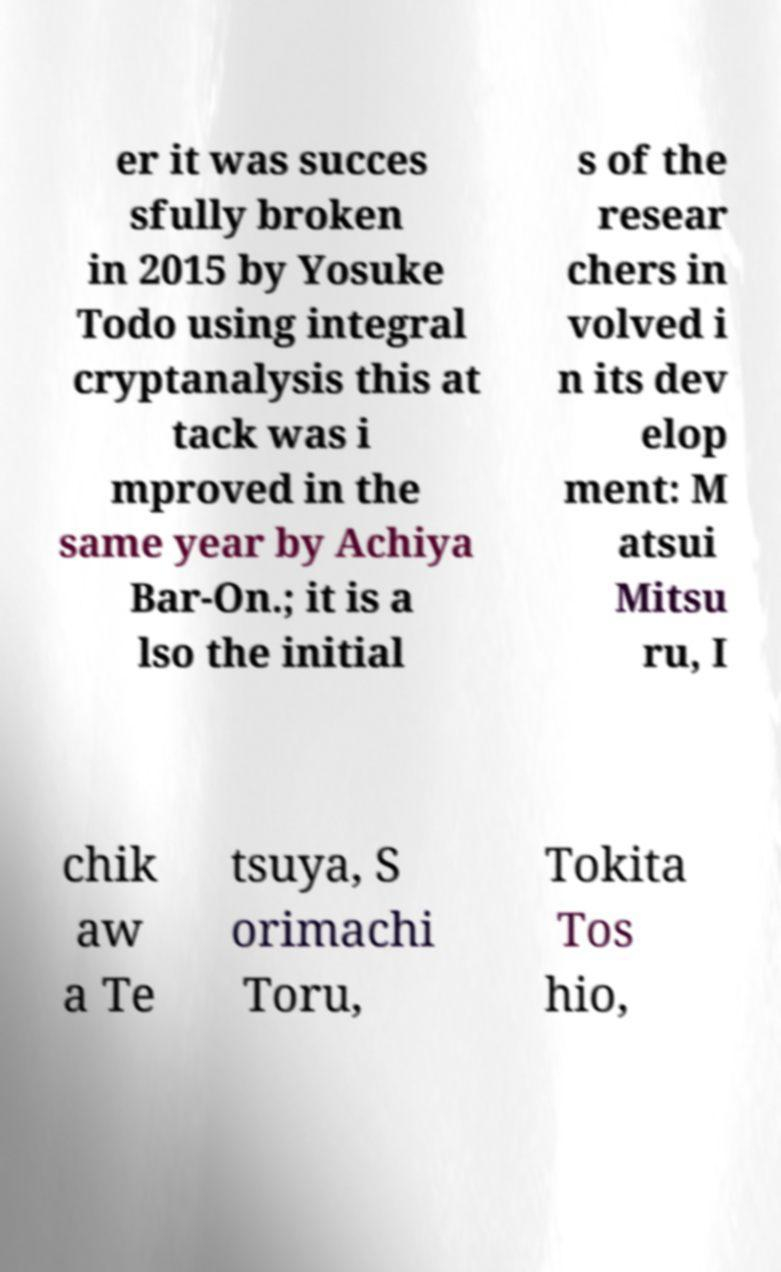Can you read and provide the text displayed in the image?This photo seems to have some interesting text. Can you extract and type it out for me? er it was succes sfully broken in 2015 by Yosuke Todo using integral cryptanalysis this at tack was i mproved in the same year by Achiya Bar-On.; it is a lso the initial s of the resear chers in volved i n its dev elop ment: M atsui Mitsu ru, I chik aw a Te tsuya, S orimachi Toru, Tokita Tos hio, 